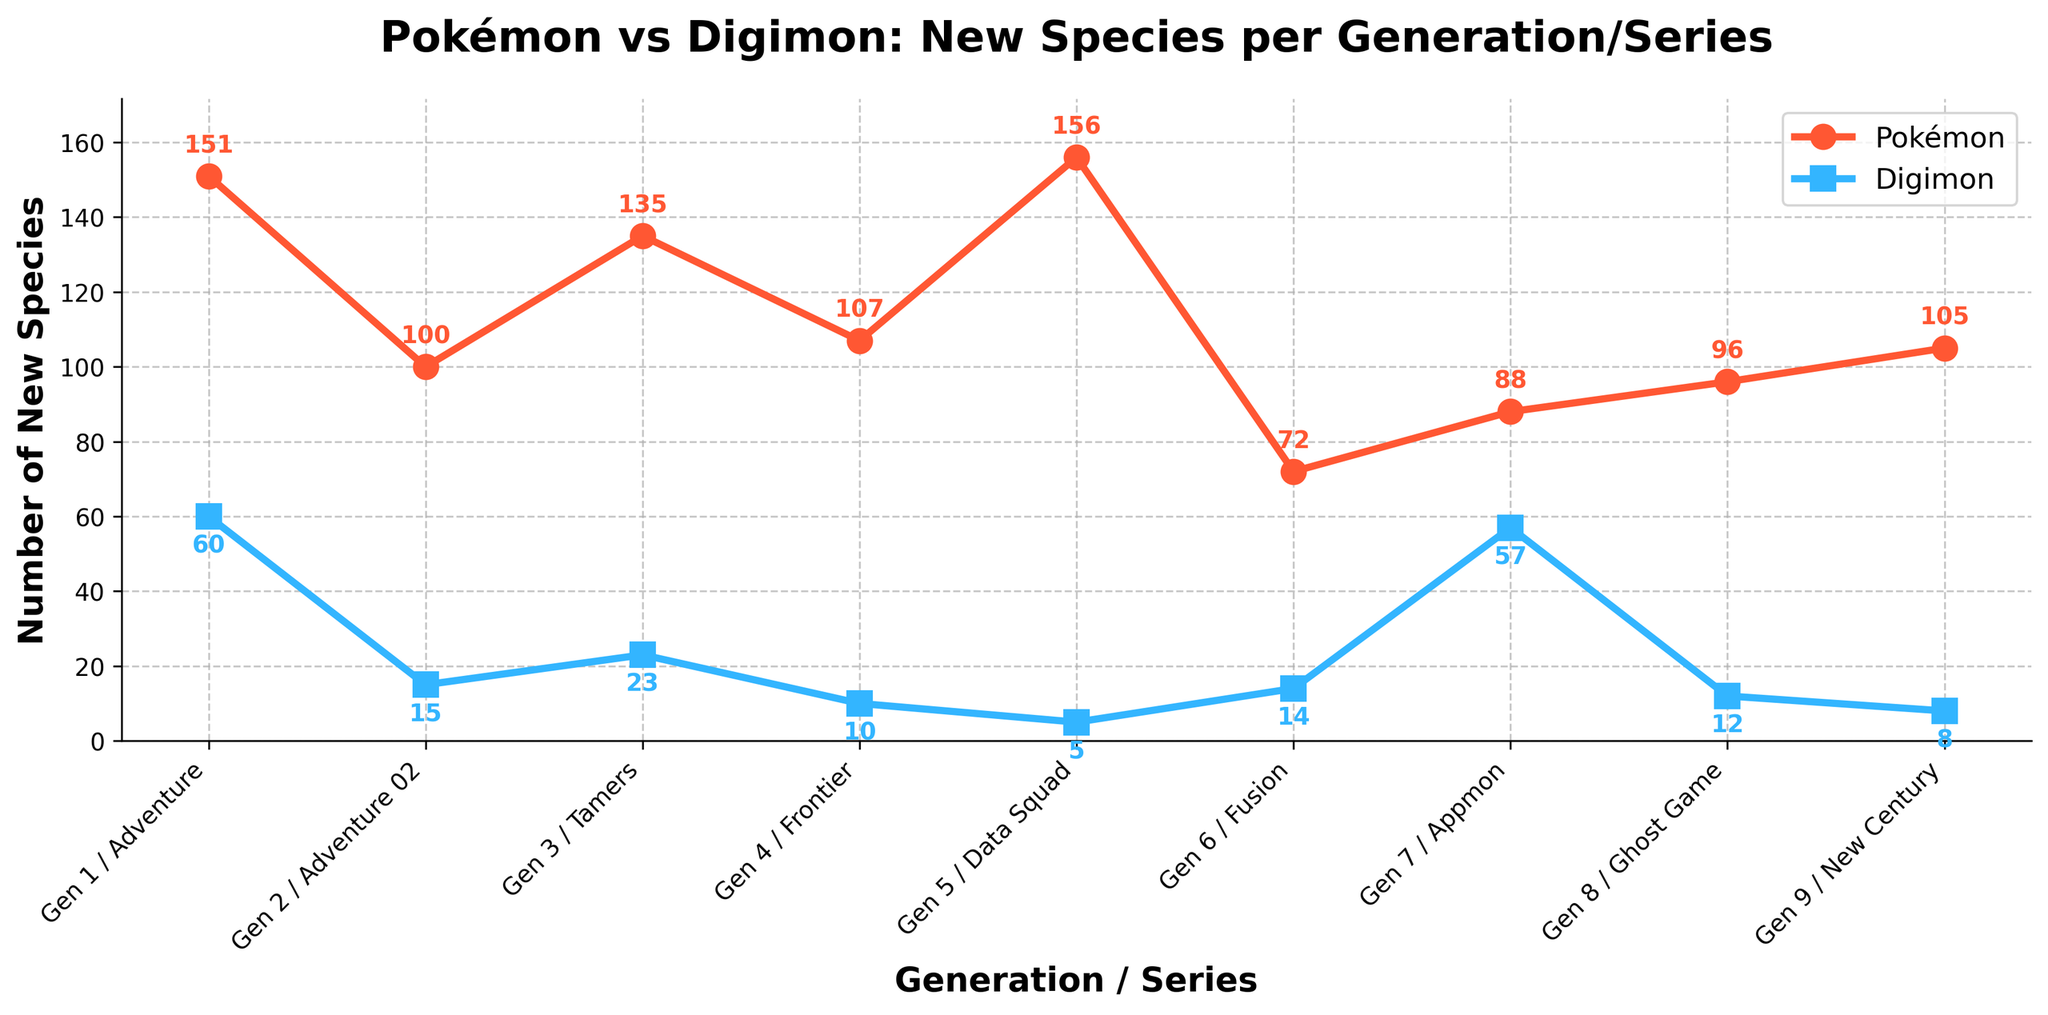How many more species were introduced in Gen 5 compared to Data Squad? To find the difference, subtract the number of new Digimon species introduced in Data Squad from the new Pokemon species in Gen 5. That is, 156 - 5 = 151
Answer: 151 Which series has the lowest number of new Digimon species? By examining the series with the lowest points on the Digimon line, we observe that Data Squad has the fewest new species at 5.
Answer: Data Squad During which generation/series did Pokémon introduce fewer new species than Digimon? By comparing the points, we see that in the Appmon series, Pokémon (88) introduced fewer new species than Digimon (57).
Answer: Appmon What's the average number of new Pokémon species introduced per generation? Add all the Pokémon species counts and divide by the number of generations: (151 + 100 + 135 + 107 + 156 + 72 + 88 + 96 + 105) / 9 = 1011 / 9 ≈ 112.33
Answer: 112.33 Between Gen 1 (Adventure) and Gen 2 (Adventure 02), which introduced more new species overall, and by how many? By adding both Pokémon and Digimon species for each: Gen 1/Adventure total is 151 + 60 = 211, Gen 2/Adventure 02 total is 100 + 15 = 115. Comparing gives 211 - 115 = 96. Gen 1/Adventure introduced 96 more species.
Answer: Gen 1/Adventure, 96 In which generation did Pokémon see a significant drop in the number of new species compared to the previous generation? By reviewing the data points, we see a significant drop from Gen 5 (156) to Gen 6 (72), with a difference of 156 - 72 = 84.
Answer: Gen 6 How many total new species were introduced across both Pokémon and Digimon in Gen 7 (Appmon) combined? Sum the Pokémon and Digimon species for Appmon: 88 + 57 = 145
Answer: 145 What was the highest number of new species introduced in any single generation or series by each franchise? The highest number of new Pokémon species was in Gen 5 at 156, and for Digimon, it was in Gen 1/Adventure at 60.
Answer: 156 (Pokémon), 60 (Digimon) Compare the overall trend in new species introduction for Pokémon and Digimon across the generations. Explain how the Pokémon line generally shows higher values and more consistency in the number of new species introduced, while the Digimon line fluctuates more and generally has fewer species overall.
Answer: Pokémon introduces more species consistently; Digimon fluctuates and introduces fewer species 